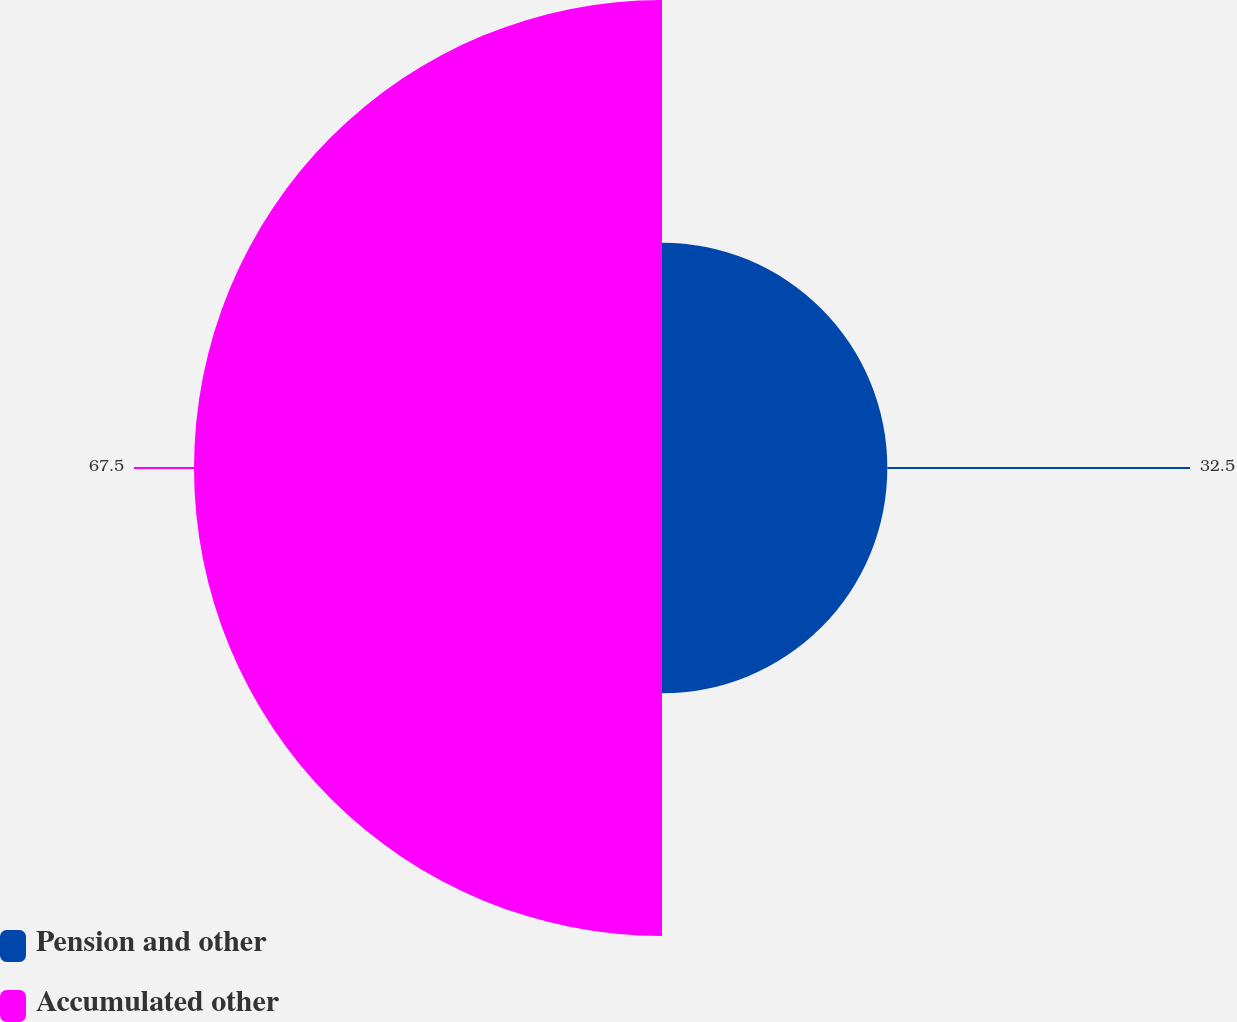<chart> <loc_0><loc_0><loc_500><loc_500><pie_chart><fcel>Pension and other<fcel>Accumulated other<nl><fcel>32.5%<fcel>67.5%<nl></chart> 